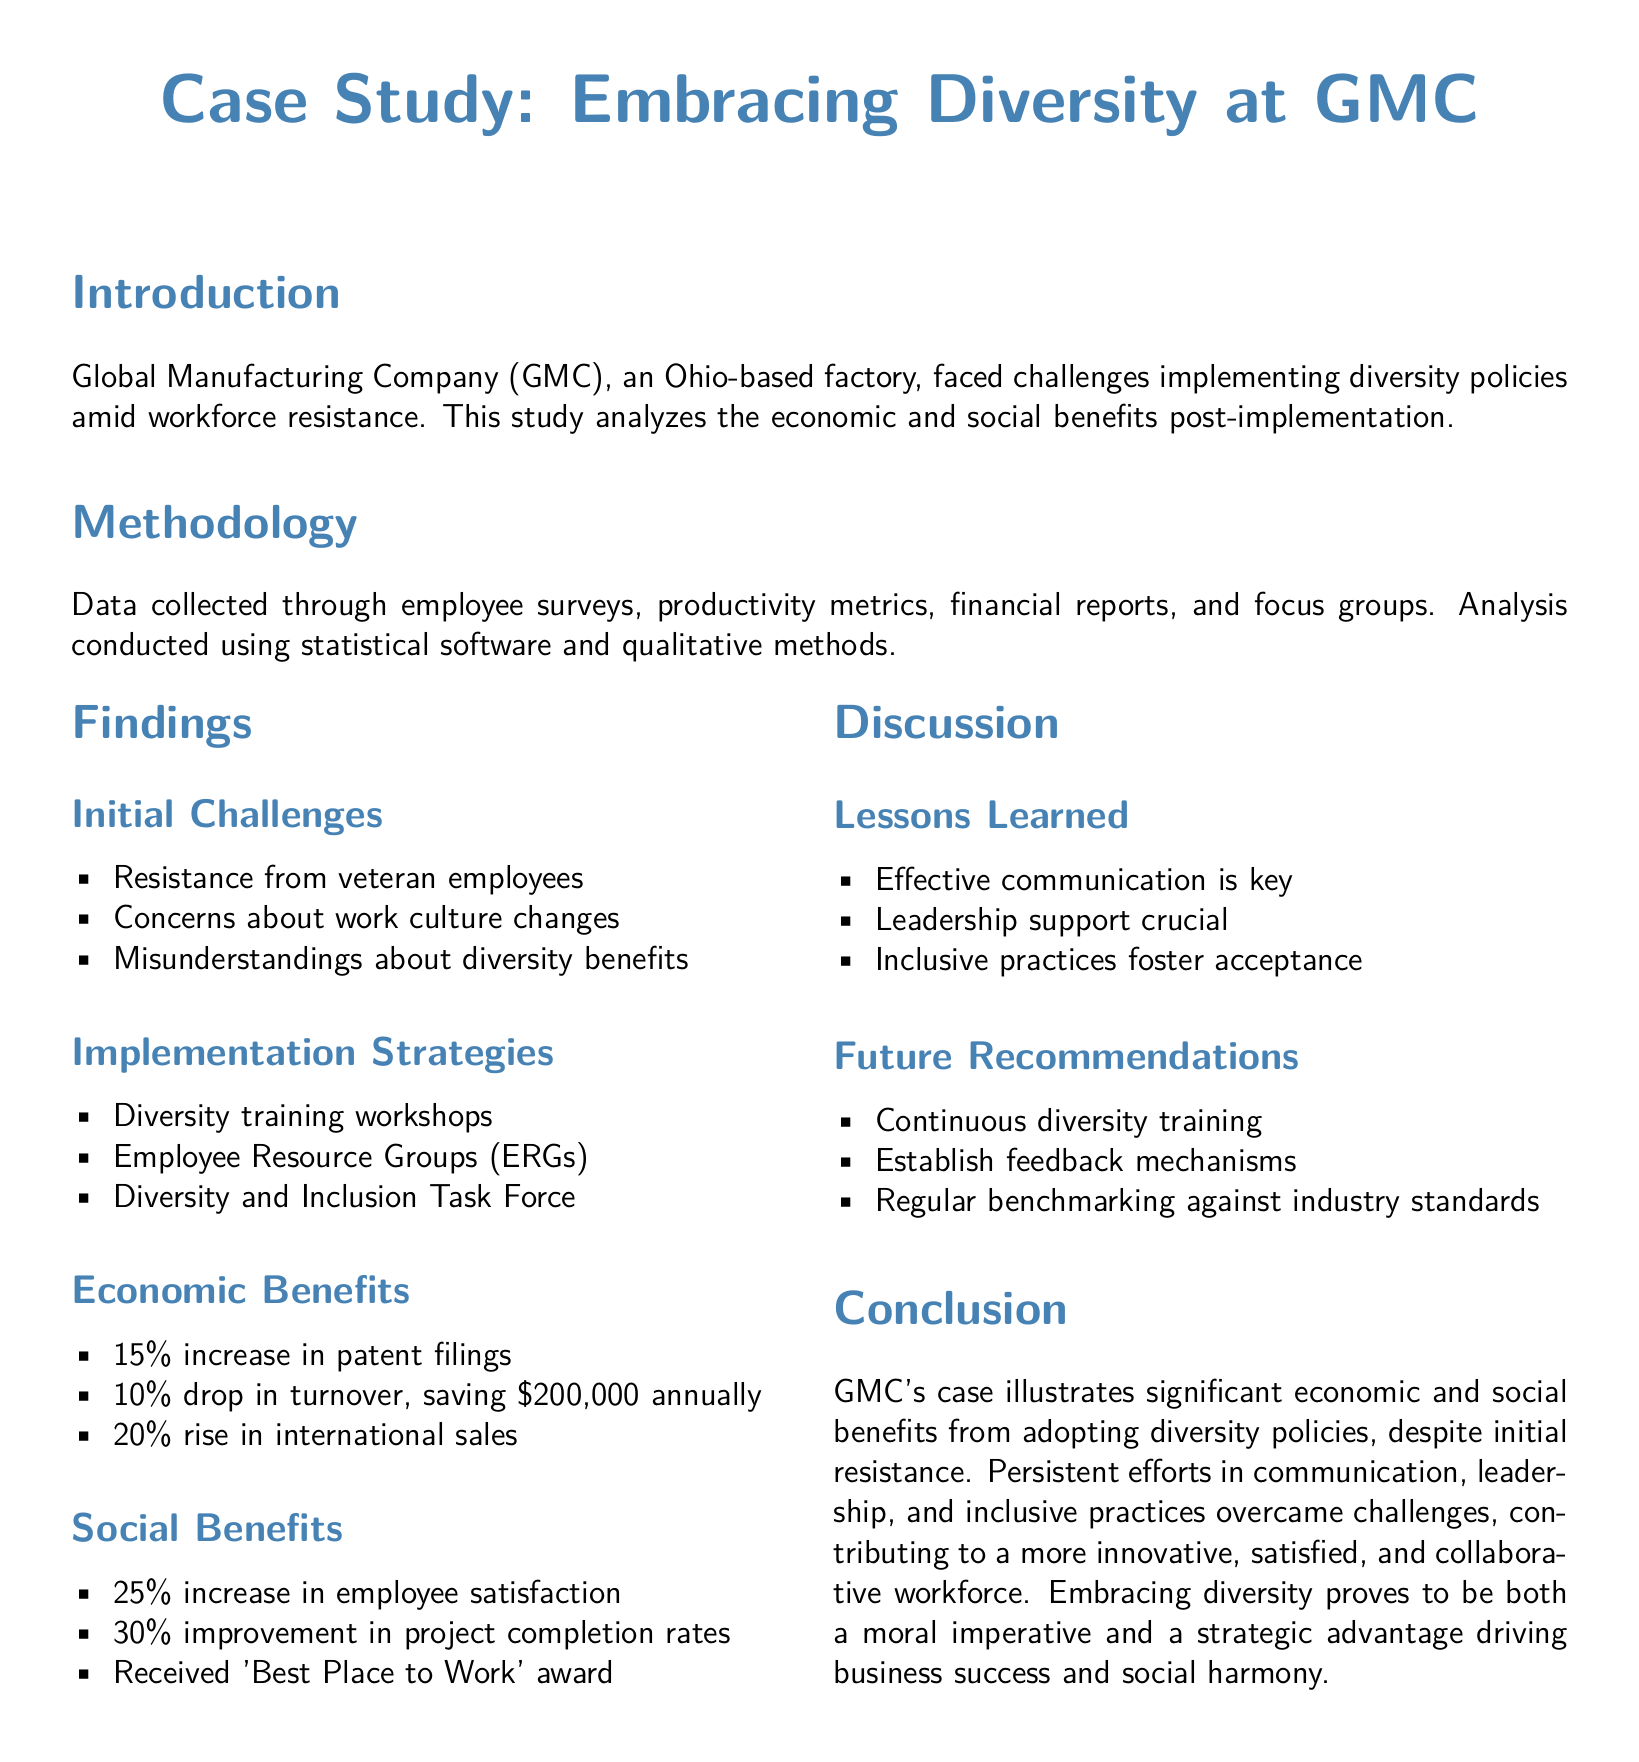what was the increase in patent filings? The document states there was a 15% increase in patent filings after the implementation of diversity policies.
Answer: 15% what was the annual savings from the drop in turnover? The turnover decreased by 10%, which saved the company $200,000 annually.
Answer: $200,000 what percentage of employee satisfaction increased? The findings show a 25% increase in employee satisfaction after diversity initiatives were introduced.
Answer: 25% what was a significant strategy for implementation? One of the strategies highlighted in the document is the establishment of Employee Resource Groups (ERGs).
Answer: Employee Resource Groups (ERGs) what award did GMC receive? The document mentions that GMC received the 'Best Place to Work' award.
Answer: 'Best Place to Work' why is leadership support crucial? Leadership support is crucial as it fosters acceptance and communicates the importance of diversity policies to the workforce.
Answer: fosters acceptance how much did international sales rise by? The analysis noted a 20% rise in international sales after the implementation of diversity policies.
Answer: 20% what is a lesson learned regarding communication? The document emphasizes that effective communication is key to successfully implementing diversity policies.
Answer: effective communication what future recommendation is suggested? One recommendation for the future is to establish feedback mechanisms to improve diversity initiatives.
Answer: establish feedback mechanisms 